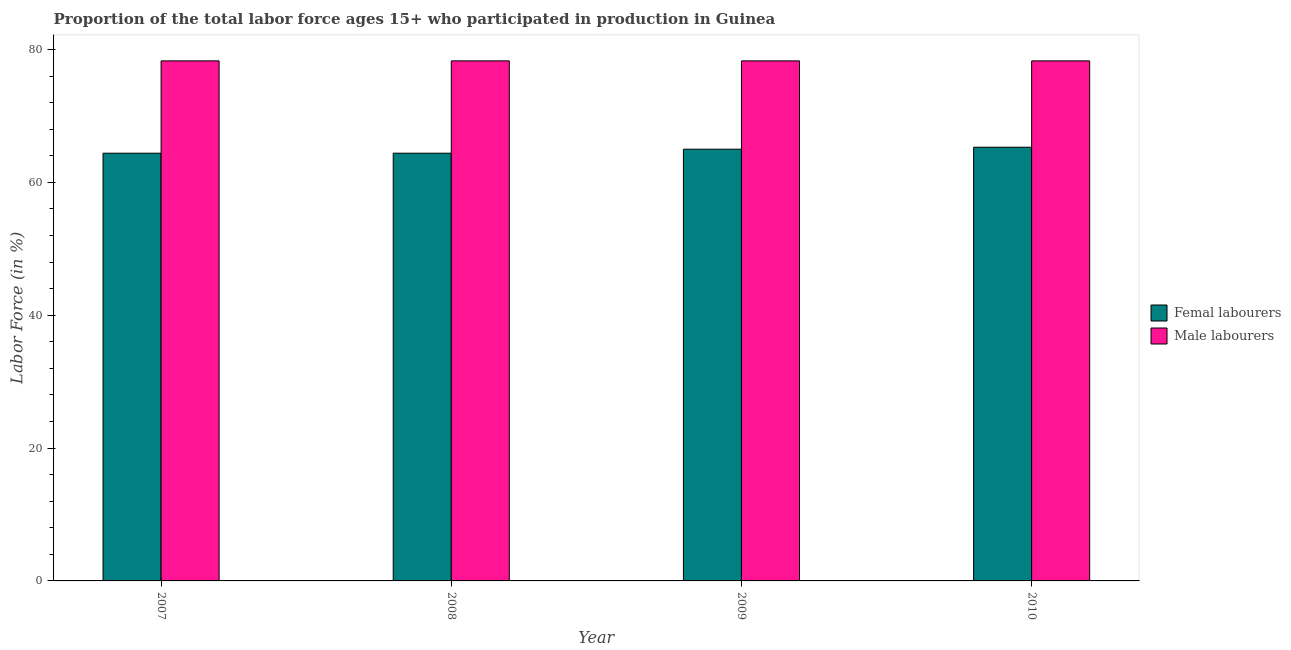How many different coloured bars are there?
Give a very brief answer. 2. How many groups of bars are there?
Give a very brief answer. 4. In how many cases, is the number of bars for a given year not equal to the number of legend labels?
Your answer should be very brief. 0. What is the percentage of male labour force in 2008?
Keep it short and to the point. 78.3. Across all years, what is the maximum percentage of male labour force?
Your answer should be very brief. 78.3. Across all years, what is the minimum percentage of female labor force?
Your response must be concise. 64.4. In which year was the percentage of female labor force maximum?
Your answer should be very brief. 2010. What is the total percentage of male labour force in the graph?
Keep it short and to the point. 313.2. What is the average percentage of female labor force per year?
Your answer should be compact. 64.78. In the year 2009, what is the difference between the percentage of female labor force and percentage of male labour force?
Your answer should be very brief. 0. In how many years, is the percentage of female labor force greater than 36 %?
Give a very brief answer. 4. What is the ratio of the percentage of male labour force in 2008 to that in 2010?
Give a very brief answer. 1. What is the difference between the highest and the second highest percentage of male labour force?
Make the answer very short. 0. What is the difference between the highest and the lowest percentage of male labour force?
Keep it short and to the point. 0. What does the 2nd bar from the left in 2008 represents?
Ensure brevity in your answer.  Male labourers. What does the 1st bar from the right in 2007 represents?
Offer a terse response. Male labourers. How many bars are there?
Give a very brief answer. 8. Are all the bars in the graph horizontal?
Your answer should be compact. No. Are the values on the major ticks of Y-axis written in scientific E-notation?
Your answer should be compact. No. Does the graph contain any zero values?
Your answer should be compact. No. How many legend labels are there?
Your answer should be compact. 2. What is the title of the graph?
Your answer should be compact. Proportion of the total labor force ages 15+ who participated in production in Guinea. What is the label or title of the Y-axis?
Ensure brevity in your answer.  Labor Force (in %). What is the Labor Force (in %) of Femal labourers in 2007?
Provide a succinct answer. 64.4. What is the Labor Force (in %) of Male labourers in 2007?
Provide a short and direct response. 78.3. What is the Labor Force (in %) in Femal labourers in 2008?
Provide a short and direct response. 64.4. What is the Labor Force (in %) in Male labourers in 2008?
Offer a very short reply. 78.3. What is the Labor Force (in %) of Male labourers in 2009?
Give a very brief answer. 78.3. What is the Labor Force (in %) of Femal labourers in 2010?
Your answer should be compact. 65.3. What is the Labor Force (in %) in Male labourers in 2010?
Ensure brevity in your answer.  78.3. Across all years, what is the maximum Labor Force (in %) of Femal labourers?
Keep it short and to the point. 65.3. Across all years, what is the maximum Labor Force (in %) of Male labourers?
Make the answer very short. 78.3. Across all years, what is the minimum Labor Force (in %) in Femal labourers?
Offer a terse response. 64.4. Across all years, what is the minimum Labor Force (in %) in Male labourers?
Ensure brevity in your answer.  78.3. What is the total Labor Force (in %) in Femal labourers in the graph?
Your answer should be compact. 259.1. What is the total Labor Force (in %) of Male labourers in the graph?
Give a very brief answer. 313.2. What is the difference between the Labor Force (in %) in Femal labourers in 2007 and that in 2008?
Ensure brevity in your answer.  0. What is the difference between the Labor Force (in %) in Male labourers in 2007 and that in 2008?
Offer a terse response. 0. What is the difference between the Labor Force (in %) of Femal labourers in 2007 and that in 2009?
Provide a short and direct response. -0.6. What is the difference between the Labor Force (in %) of Male labourers in 2007 and that in 2010?
Provide a short and direct response. 0. What is the difference between the Labor Force (in %) of Femal labourers in 2008 and that in 2009?
Offer a very short reply. -0.6. What is the difference between the Labor Force (in %) in Male labourers in 2008 and that in 2010?
Keep it short and to the point. 0. What is the difference between the Labor Force (in %) of Male labourers in 2009 and that in 2010?
Ensure brevity in your answer.  0. What is the difference between the Labor Force (in %) in Femal labourers in 2007 and the Labor Force (in %) in Male labourers in 2008?
Provide a succinct answer. -13.9. What is the difference between the Labor Force (in %) of Femal labourers in 2007 and the Labor Force (in %) of Male labourers in 2009?
Offer a terse response. -13.9. What is the difference between the Labor Force (in %) of Femal labourers in 2009 and the Labor Force (in %) of Male labourers in 2010?
Keep it short and to the point. -13.3. What is the average Labor Force (in %) of Femal labourers per year?
Your answer should be compact. 64.78. What is the average Labor Force (in %) of Male labourers per year?
Keep it short and to the point. 78.3. In the year 2007, what is the difference between the Labor Force (in %) in Femal labourers and Labor Force (in %) in Male labourers?
Ensure brevity in your answer.  -13.9. What is the ratio of the Labor Force (in %) of Femal labourers in 2007 to that in 2009?
Offer a terse response. 0.99. What is the ratio of the Labor Force (in %) in Femal labourers in 2007 to that in 2010?
Provide a short and direct response. 0.99. What is the ratio of the Labor Force (in %) in Femal labourers in 2008 to that in 2010?
Ensure brevity in your answer.  0.99. What is the difference between the highest and the second highest Labor Force (in %) of Femal labourers?
Make the answer very short. 0.3. What is the difference between the highest and the second highest Labor Force (in %) of Male labourers?
Offer a very short reply. 0. What is the difference between the highest and the lowest Labor Force (in %) of Femal labourers?
Give a very brief answer. 0.9. What is the difference between the highest and the lowest Labor Force (in %) of Male labourers?
Offer a very short reply. 0. 